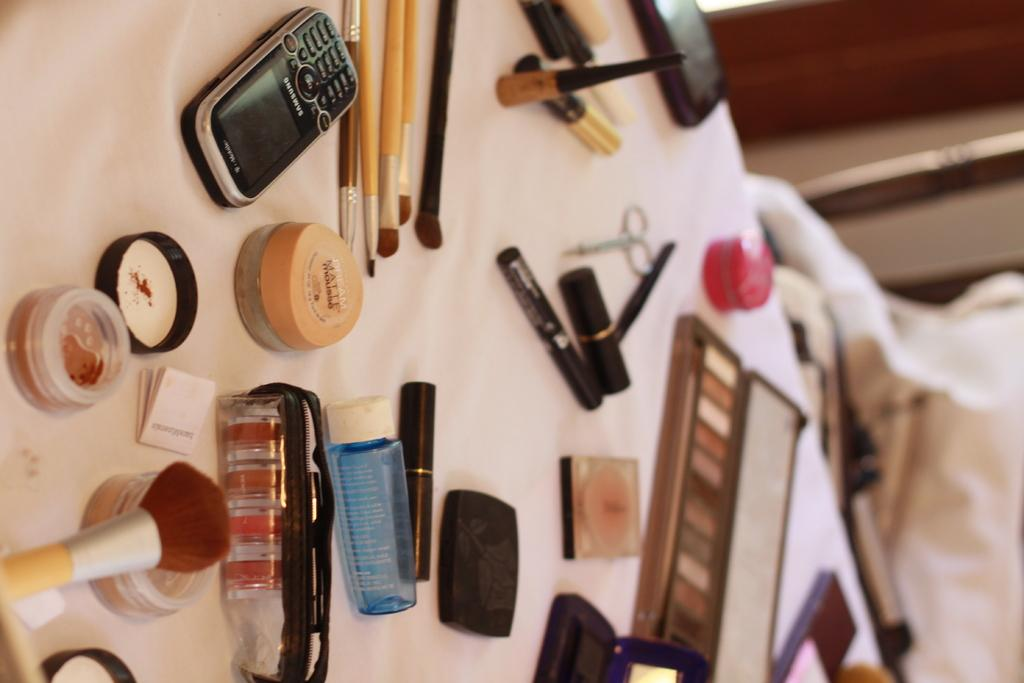Provide a one-sentence caption for the provided image. A black Samsung phone sits on a table next to cosmetics. 